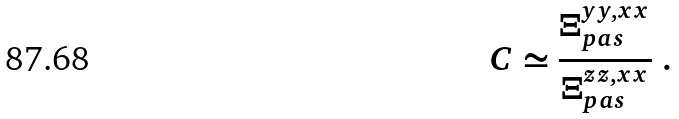<formula> <loc_0><loc_0><loc_500><loc_500>C \simeq \frac { \Xi ^ { y y , x x } _ { p a s } } { \Xi ^ { z z , x x } _ { p a s } } \ .</formula> 